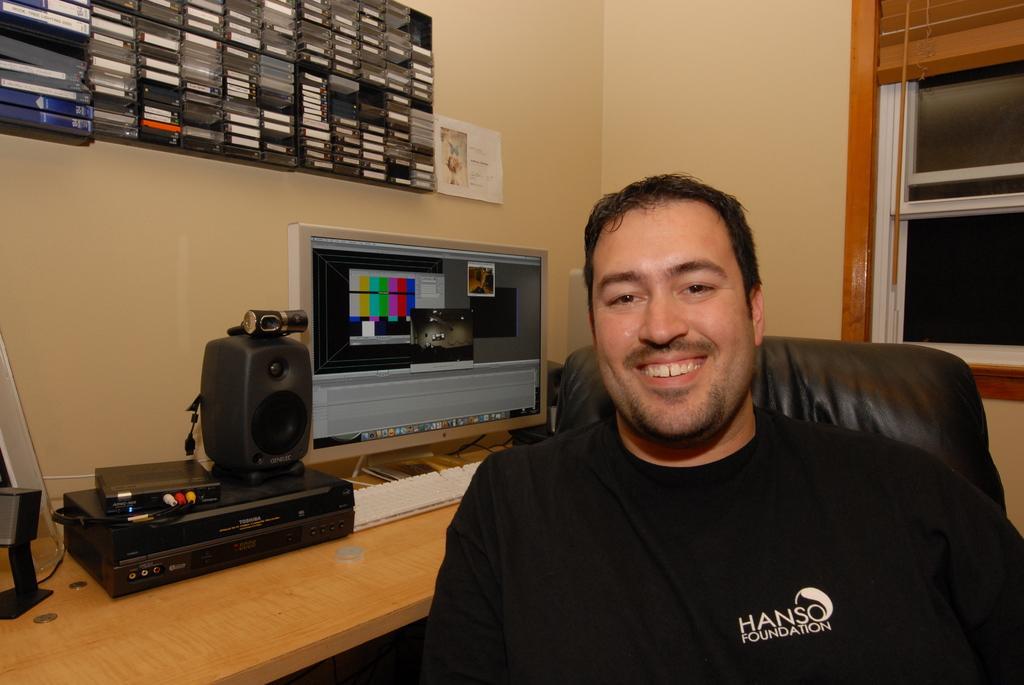Please provide a concise description of this image. The man in front of the picture wearing the black T-shirt is sitting on the chair and he is smiling. Beside him, we see a table on which speaker, monitor, keyboard and music player are placed. Behind that, we see a wall on which poster is pasted. Beside that, we see the shelves in which many CDs and DVDs are placed. On the right side, we see a glass window. 